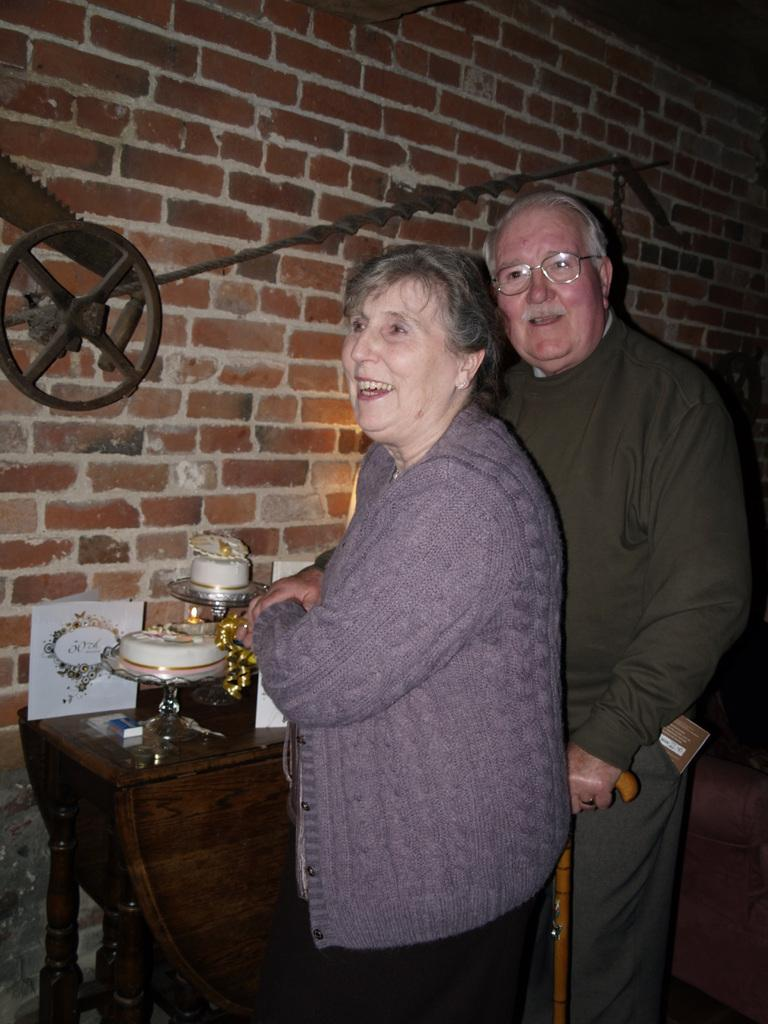Who are the people in the image? There is an old man and an old woman in the image. What are they doing in the image? They are standing in front of a table. What can be seen on the table? There is an object on the table. What is the old man holding in his hand? The old man is holding a stick in his hand. What type of guitar is the old man playing in the image? There is no guitar present in the image; the old man is holding a stick. How many legs does the old woman have in the image? The image does not show the legs of the old woman, so it is not possible to determine the number of legs she has. 